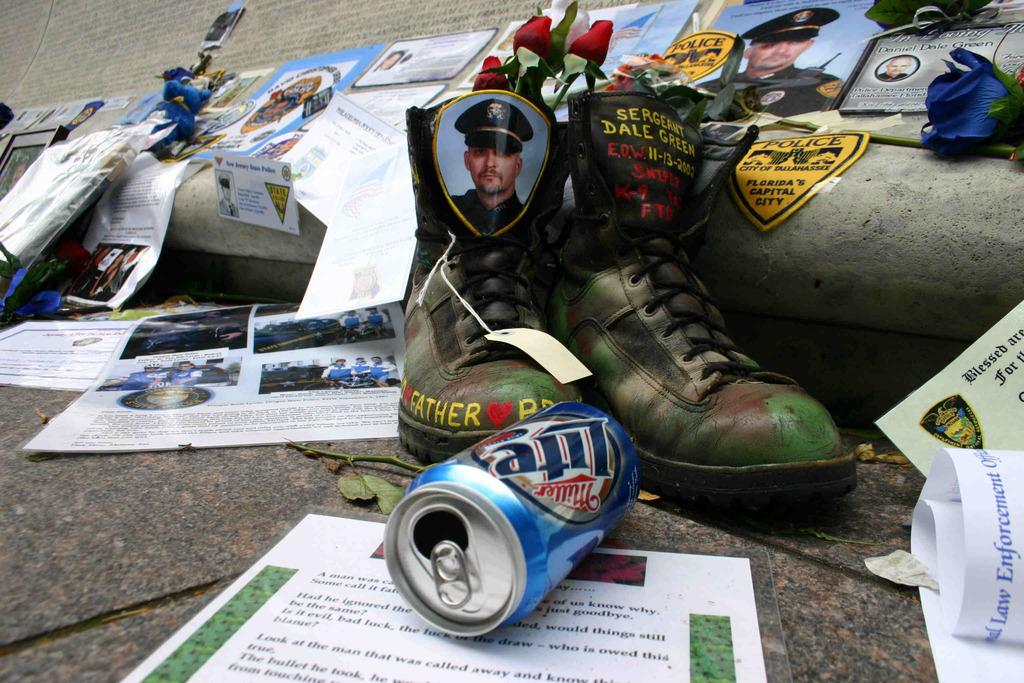What type of shoes are featured in the image? There is a pair of shoes with red roses in the image. What is the subject of the photograph in the image? There is a photograph of a military soldier in the image. What beverage container is visible in the image? There is a coke can in the front of the image. What type of reading material is present in the image? There are magazine papers spread around in the image. What is the manager's reaction to the detail in the image? There is no manager or specific detail mentioned in the image, so it's not possible to answer this question. 